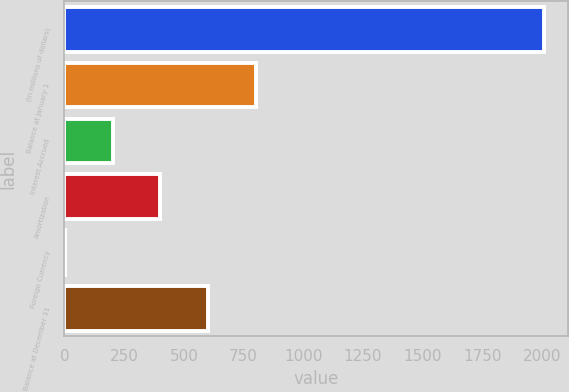Convert chart. <chart><loc_0><loc_0><loc_500><loc_500><bar_chart><fcel>(in millions of dollars)<fcel>Balance at January 1<fcel>Interest Accrued<fcel>Amortization<fcel>Foreign Currency<fcel>Balance at December 31<nl><fcel>2007<fcel>803.34<fcel>201.51<fcel>402.12<fcel>0.9<fcel>602.73<nl></chart> 